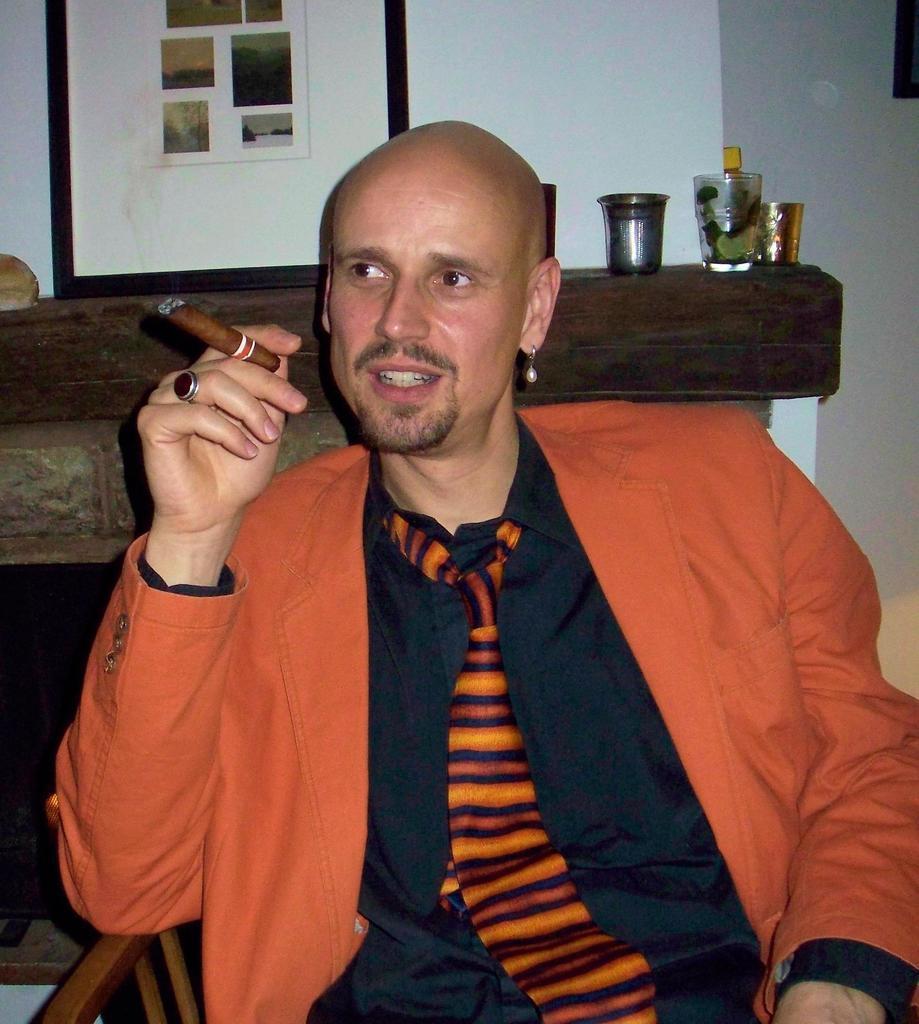How would you summarize this image in a sentence or two? In the image I can see a person who is holding the cigar and behind there is frame and some things. 